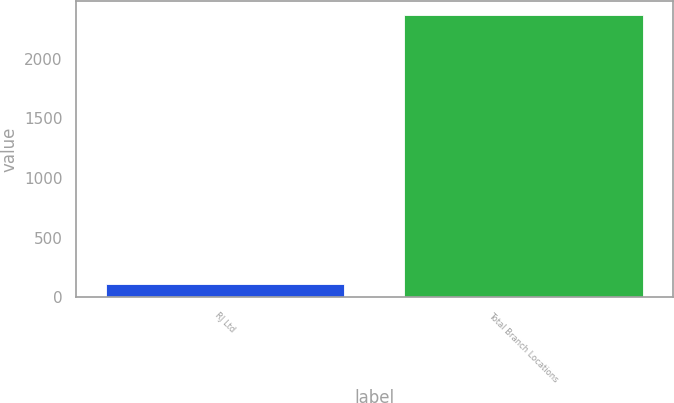Convert chart to OTSL. <chart><loc_0><loc_0><loc_500><loc_500><bar_chart><fcel>RJ Ltd<fcel>Total Branch Locations<nl><fcel>115<fcel>2364<nl></chart> 